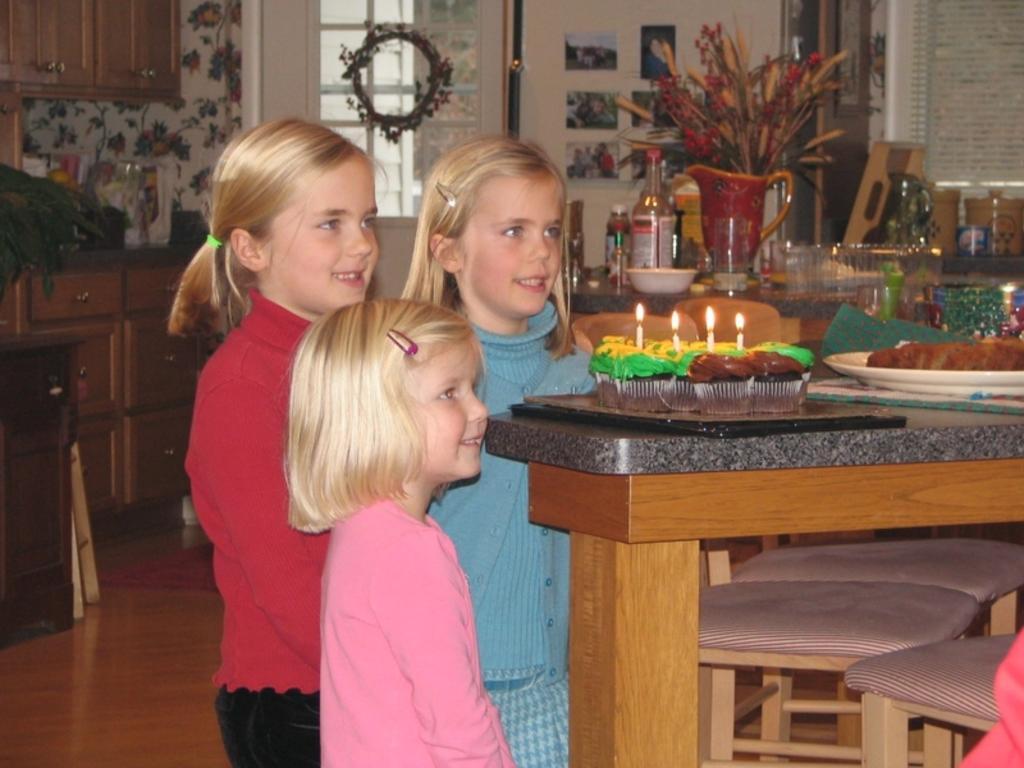Please provide a concise description of this image. 3 people are standing in a room. the person in the front is wearing pink t shirt. the person at the right back is wearing blue dress. the person at the left back is wearing a red t shirt and black pant. at the right there is a table on which there is a table on which there is a plate, black tray on which there are cupcakes and candles on it. beside that there are chairs. at the back there is a table on which there are flower pot, bowl, glass bottle, glasses. at the left back there are cupboards. at the back there is a window and a white wall on which there are photos. 